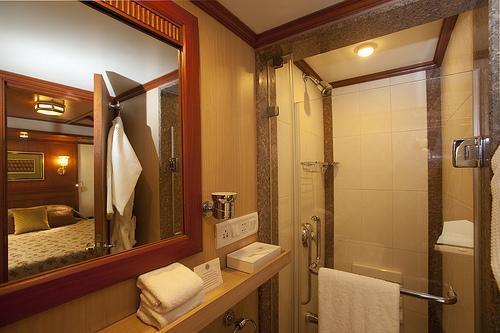How many shower heads are there?
Give a very brief answer. 1. 